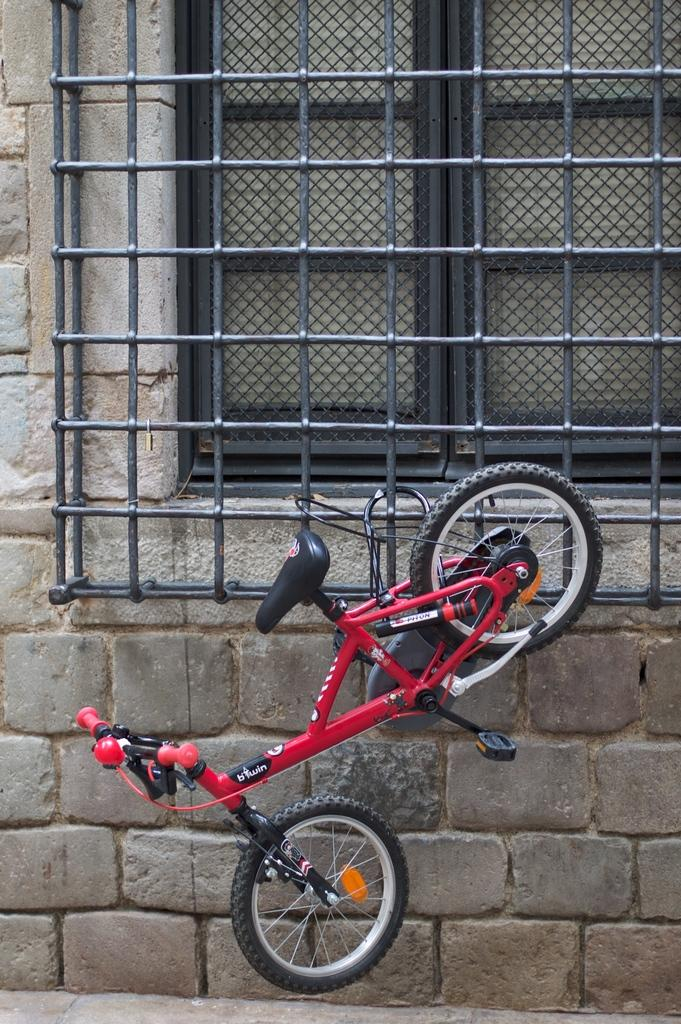What type of vehicle is in the image? There is a red bicycle in the image. How is the bicycle secured in the image? The bicycle is tied to an iron fence. What is the iron fence is attached to in the image? The iron fence is attached to a brick wall. What is the brick wall part of in the image? The brick wall is part of a building. What feature of the building is visible in the image? The building has a window. What type of path is located beside the building in the image? There is a footpath beside the building. Can you tell me how many kittens are playing in the yard in the image? There is no yard or kittens present in the image. 